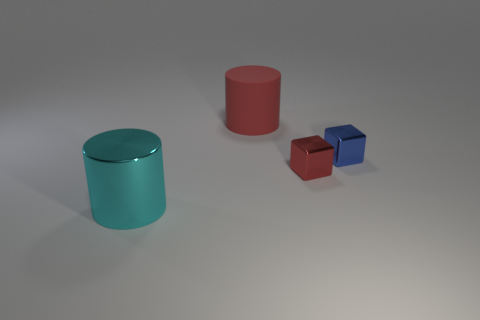Add 1 small red metallic objects. How many objects exist? 5 Subtract all big green metal objects. Subtract all large objects. How many objects are left? 2 Add 4 small blue cubes. How many small blue cubes are left? 5 Add 4 gray rubber cylinders. How many gray rubber cylinders exist? 4 Subtract 0 yellow spheres. How many objects are left? 4 